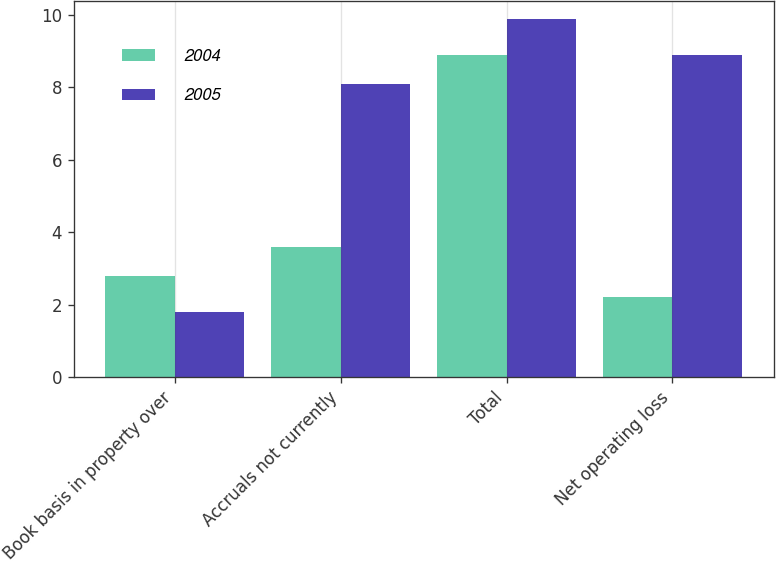Convert chart. <chart><loc_0><loc_0><loc_500><loc_500><stacked_bar_chart><ecel><fcel>Book basis in property over<fcel>Accruals not currently<fcel>Total<fcel>Net operating loss<nl><fcel>2004<fcel>2.8<fcel>3.6<fcel>8.9<fcel>2.2<nl><fcel>2005<fcel>1.8<fcel>8.1<fcel>9.9<fcel>8.9<nl></chart> 